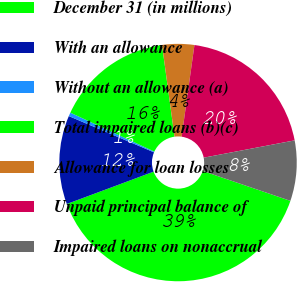Convert chart. <chart><loc_0><loc_0><loc_500><loc_500><pie_chart><fcel>December 31 (in millions)<fcel>With an allowance<fcel>Without an allowance (a)<fcel>Total impaired loans (b)(c)<fcel>Allowance for loan losses<fcel>Unpaid principal balance of<fcel>Impaired loans on nonaccrual<nl><fcel>39.09%<fcel>12.08%<fcel>0.5%<fcel>15.94%<fcel>4.36%<fcel>19.8%<fcel>8.22%<nl></chart> 